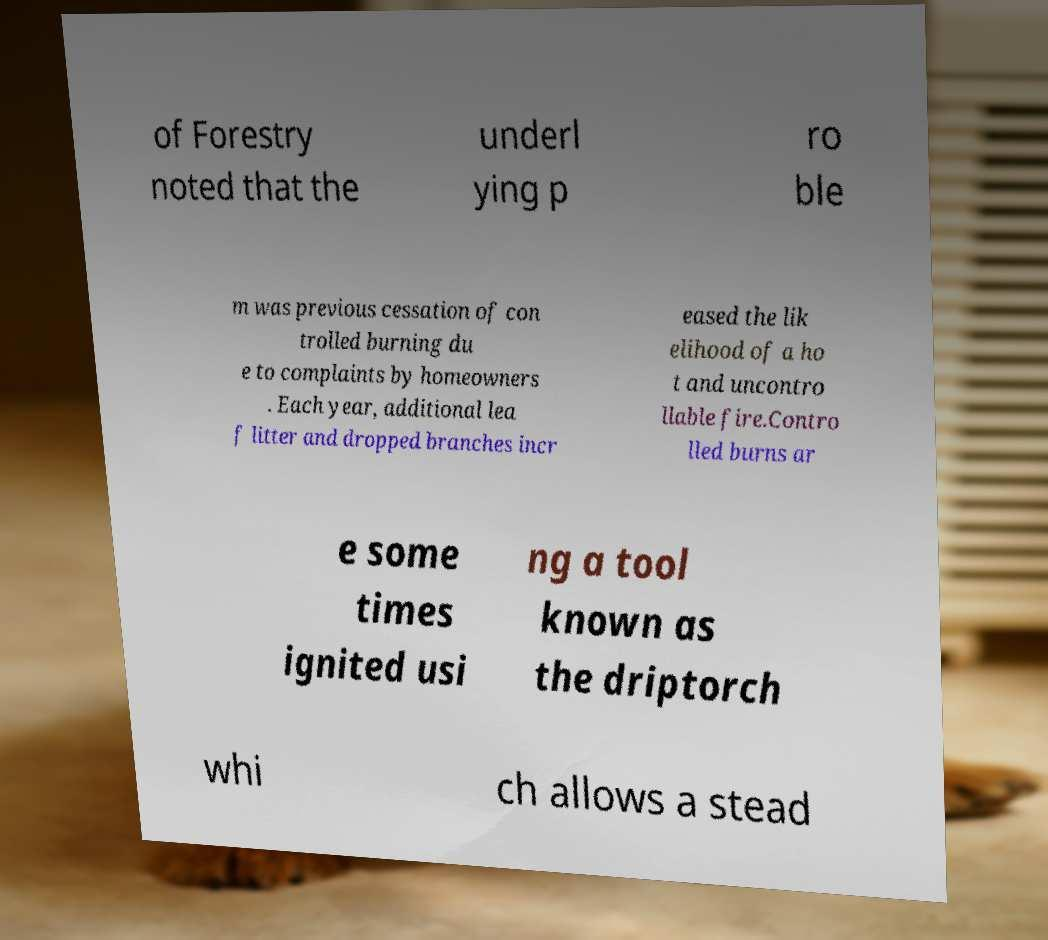Please read and relay the text visible in this image. What does it say? of Forestry noted that the underl ying p ro ble m was previous cessation of con trolled burning du e to complaints by homeowners . Each year, additional lea f litter and dropped branches incr eased the lik elihood of a ho t and uncontro llable fire.Contro lled burns ar e some times ignited usi ng a tool known as the driptorch whi ch allows a stead 